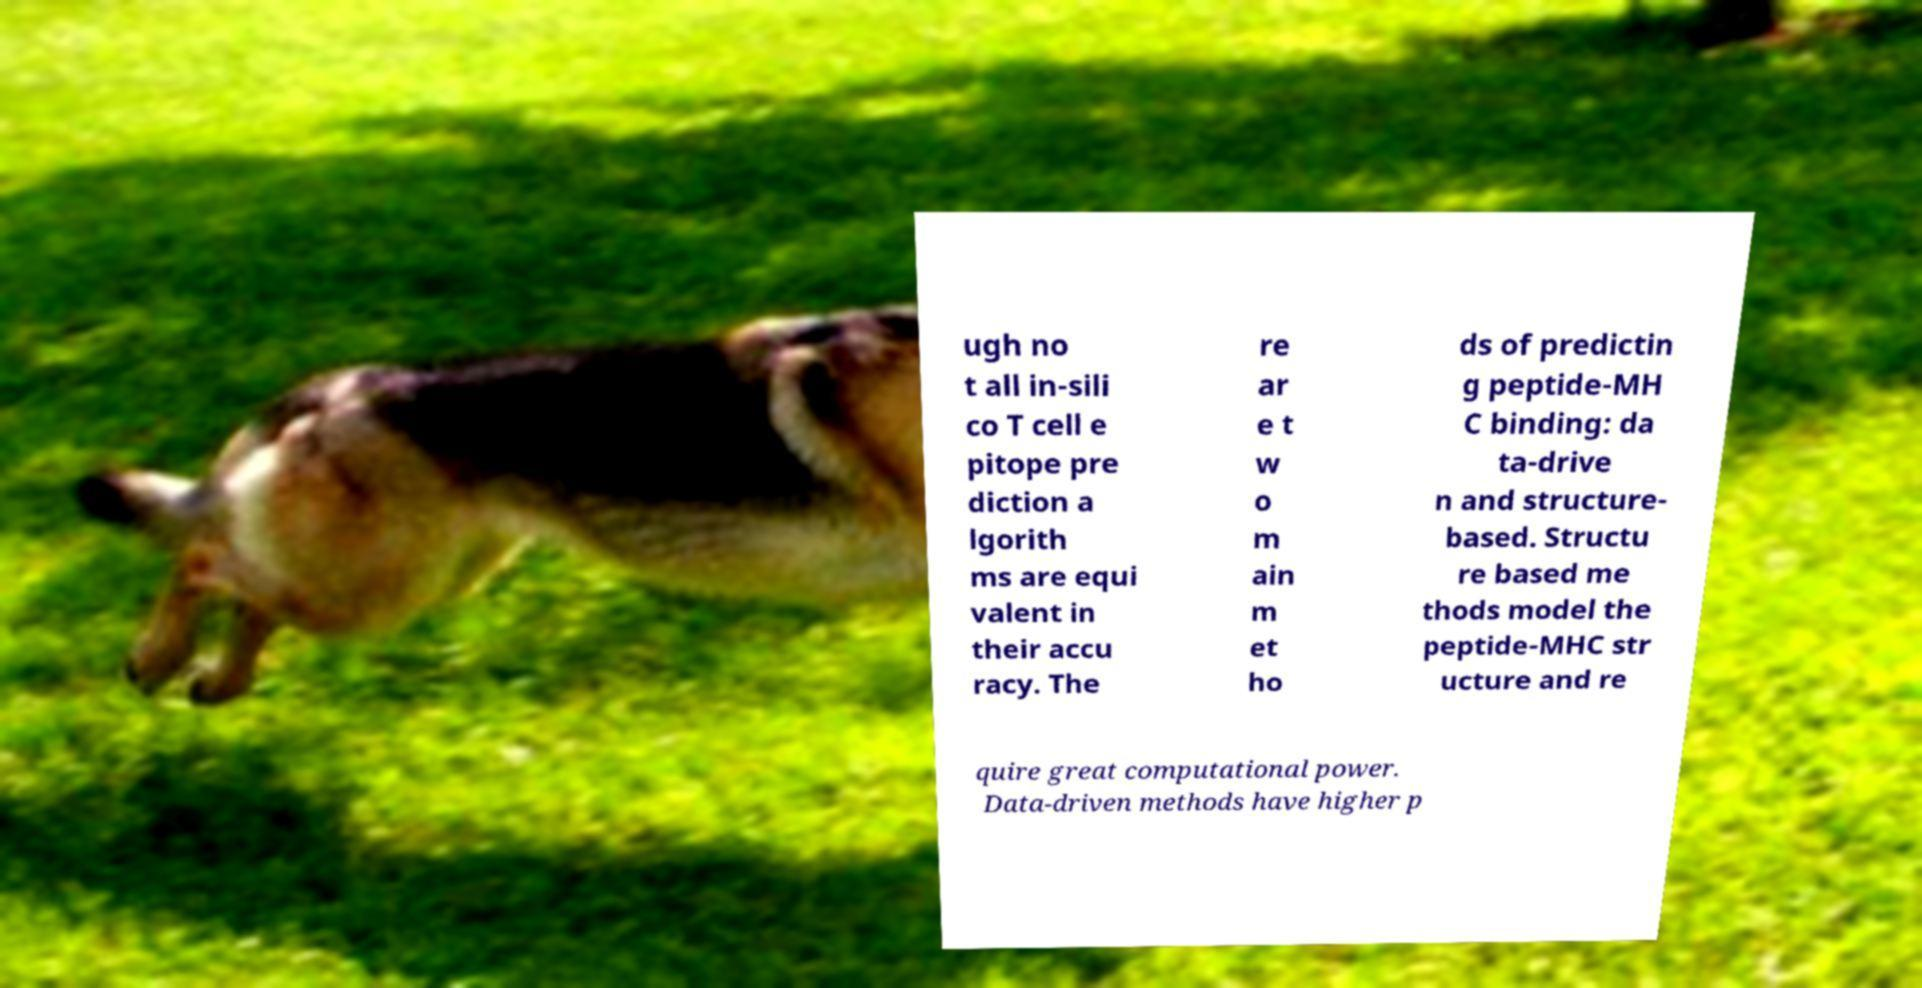Please identify and transcribe the text found in this image. ugh no t all in-sili co T cell e pitope pre diction a lgorith ms are equi valent in their accu racy. The re ar e t w o m ain m et ho ds of predictin g peptide-MH C binding: da ta-drive n and structure- based. Structu re based me thods model the peptide-MHC str ucture and re quire great computational power. Data-driven methods have higher p 